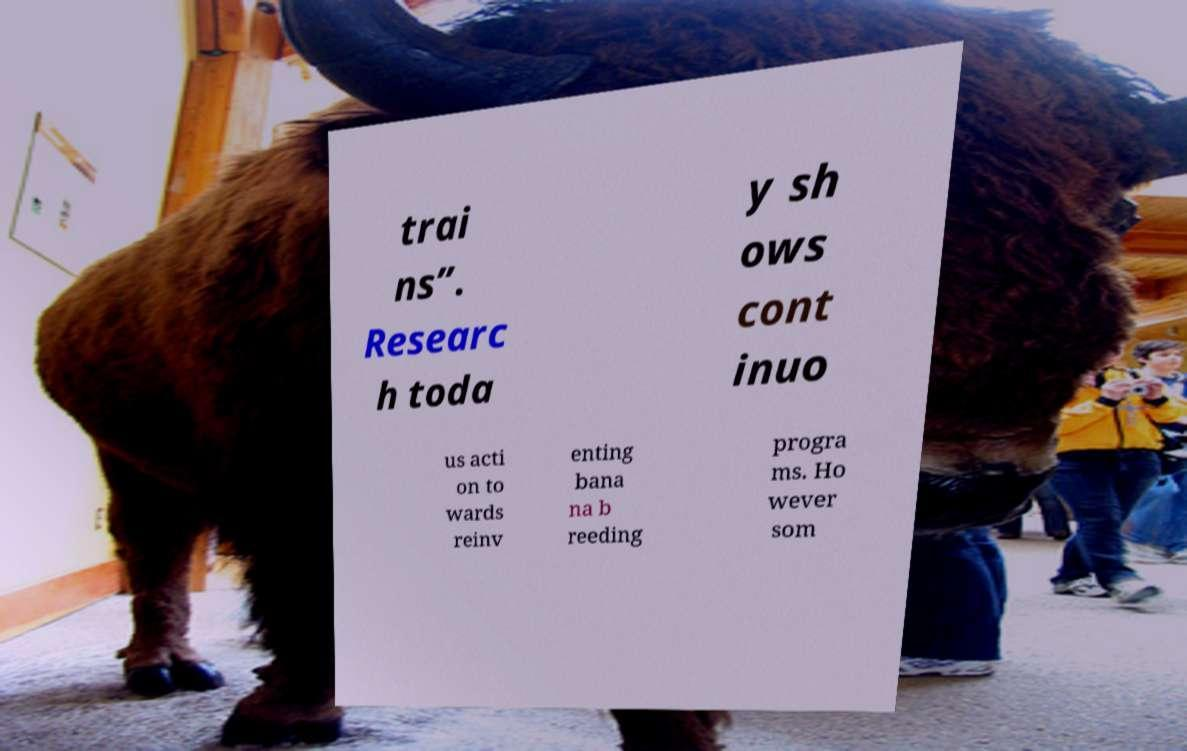What messages or text are displayed in this image? I need them in a readable, typed format. trai ns”. Researc h toda y sh ows cont inuo us acti on to wards reinv enting bana na b reeding progra ms. Ho wever som 